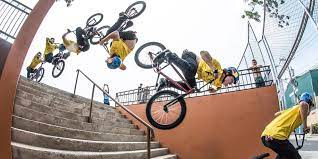How many bicycles would there be in the image if someone has deleted two bicycles from the picture? 2 